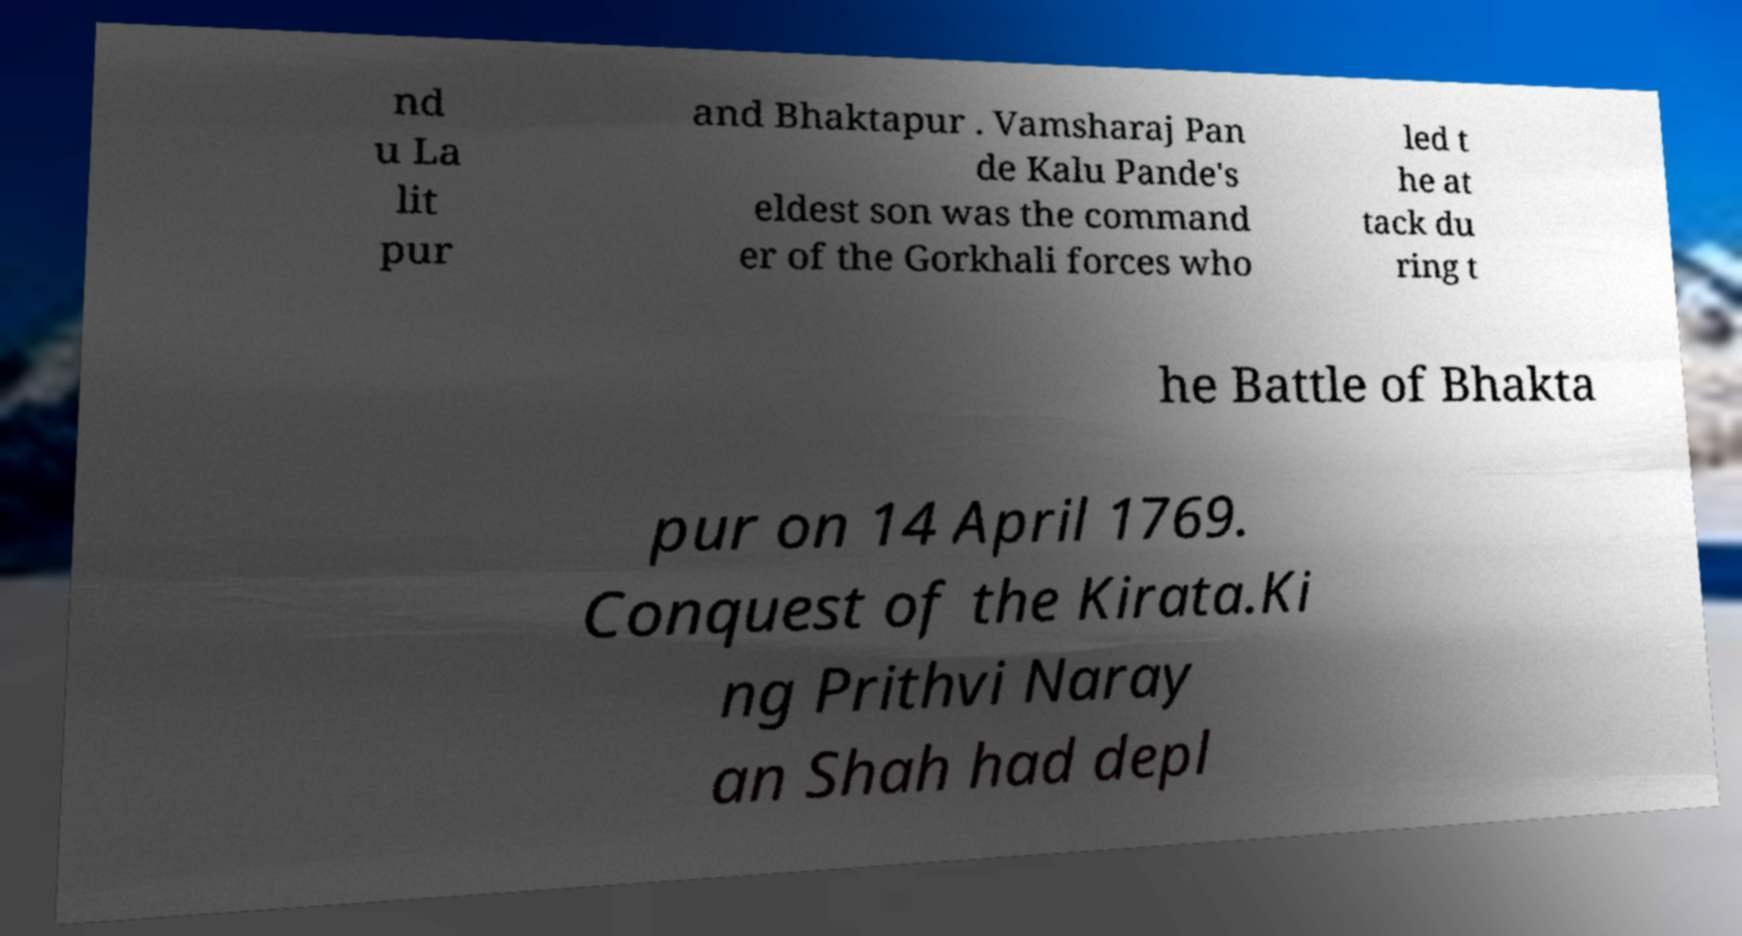Can you accurately transcribe the text from the provided image for me? nd u La lit pur and Bhaktapur . Vamsharaj Pan de Kalu Pande's eldest son was the command er of the Gorkhali forces who led t he at tack du ring t he Battle of Bhakta pur on 14 April 1769. Conquest of the Kirata.Ki ng Prithvi Naray an Shah had depl 